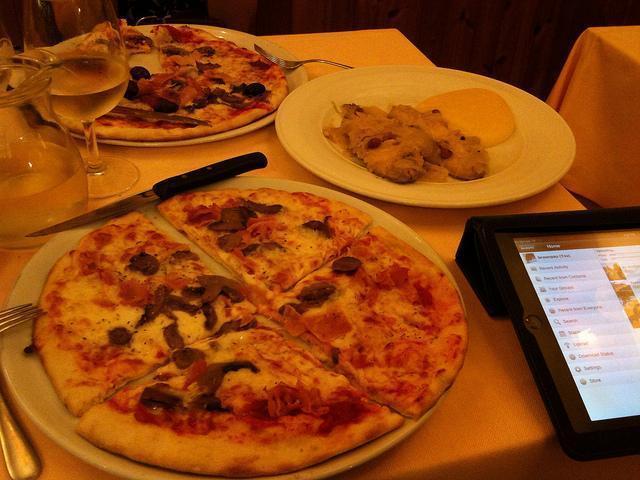How many forks are in the picture?
Give a very brief answer. 2. How many dining tables are in the photo?
Give a very brief answer. 2. How many pizzas can you see?
Give a very brief answer. 2. How many chairs are on the right side of the tree?
Give a very brief answer. 0. 